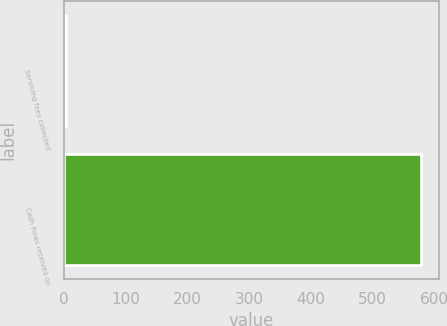Convert chart. <chart><loc_0><loc_0><loc_500><loc_500><bar_chart><fcel>Servicing fees collected<fcel>Cash flows received on<nl><fcel>4<fcel>578<nl></chart> 